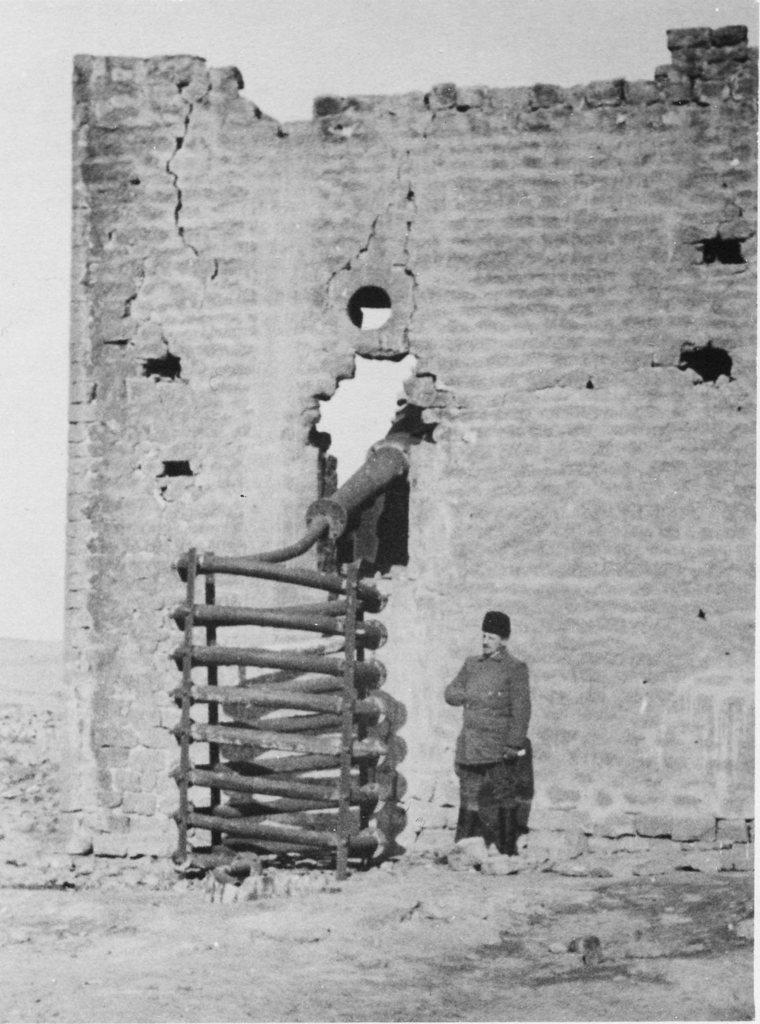Describe this image in one or two sentences. in this picture there is a broken wall in the center of the image and there is a man in the center of the image, there is a wooden rack in the center of the image. 